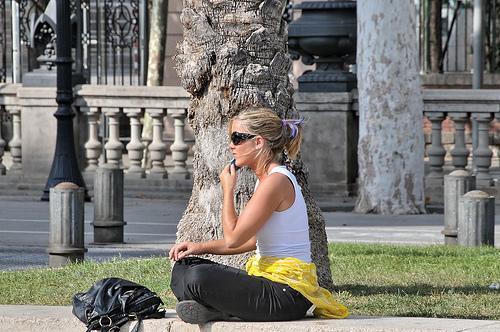How many people are there?
Give a very brief answer. 1. 